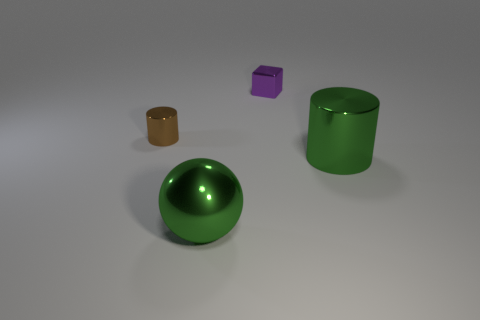Add 4 big cylinders. How many objects exist? 8 Subtract all cubes. How many objects are left? 3 Add 4 brown shiny things. How many brown shiny things are left? 5 Add 3 large green objects. How many large green objects exist? 5 Subtract 0 brown balls. How many objects are left? 4 Subtract all yellow cubes. Subtract all big things. How many objects are left? 2 